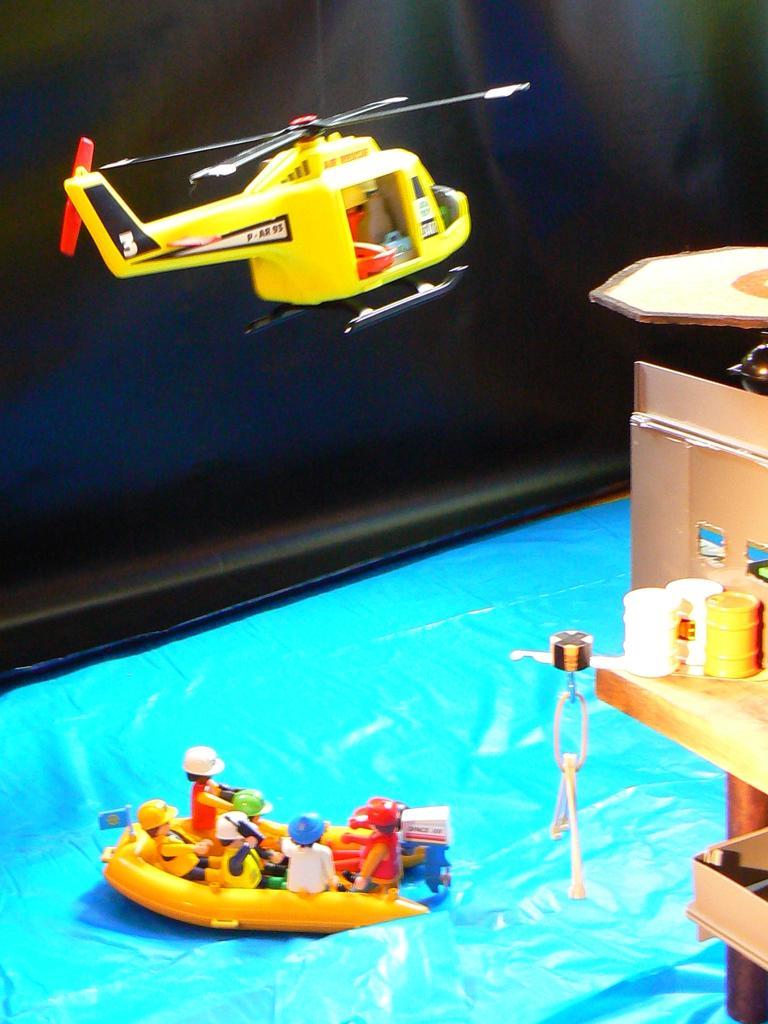Can you describe this image briefly? On the right side of this image there is a toy building. At the bottom there is a toy boat on a blue color sheet. On the boat few people are sitting. At the top of the image there is a toy helicopter flying. In the background there is a black color cloth. 